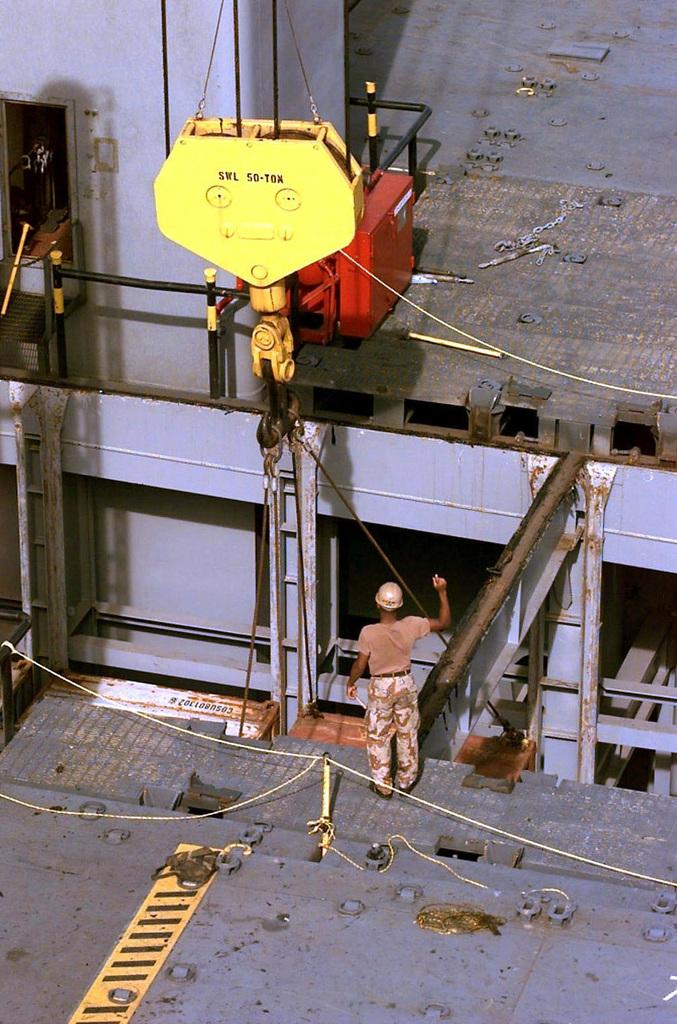What is the main subject of the image? There is a man standing in the image. What is the man wearing on his head? The man is wearing a helmet. What else can be seen in the image besides the man? There are machines and wires visible in the image. What type of cake is being served in the image? There is no cake present in the image; it features a man wearing a helmet and machines with wires. 